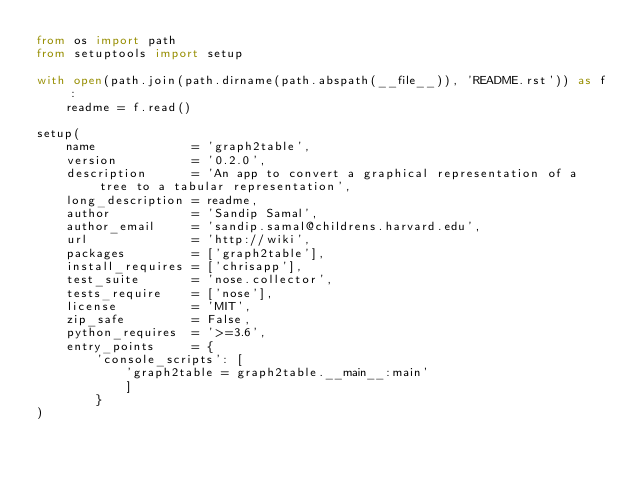Convert code to text. <code><loc_0><loc_0><loc_500><loc_500><_Python_>from os import path
from setuptools import setup

with open(path.join(path.dirname(path.abspath(__file__)), 'README.rst')) as f:
    readme = f.read()

setup(
    name             = 'graph2table',
    version          = '0.2.0',
    description      = 'An app to convert a graphical representation of a tree to a tabular representation',
    long_description = readme,
    author           = 'Sandip Samal',
    author_email     = 'sandip.samal@childrens.harvard.edu',
    url              = 'http://wiki',
    packages         = ['graph2table'],
    install_requires = ['chrisapp'],
    test_suite       = 'nose.collector',
    tests_require    = ['nose'],
    license          = 'MIT',
    zip_safe         = False,
    python_requires  = '>=3.6',
    entry_points     = {
        'console_scripts': [
            'graph2table = graph2table.__main__:main'
            ]
        }
)
</code> 